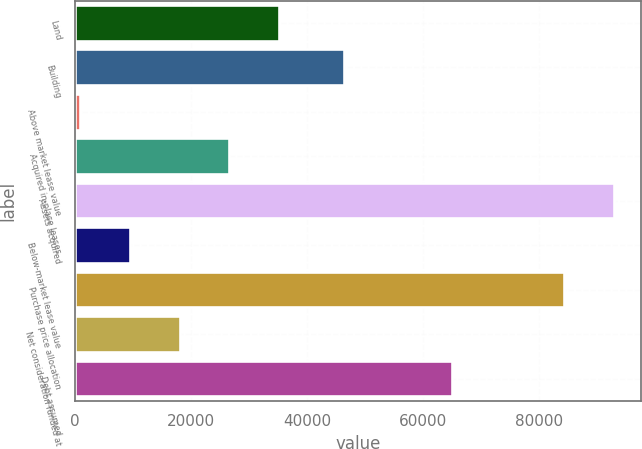<chart> <loc_0><loc_0><loc_500><loc_500><bar_chart><fcel>Land<fcel>Building<fcel>Above market lease value<fcel>Acquired in-place leases<fcel>Assets acquired<fcel>Below-market lease value<fcel>Purchase price allocation<fcel>Net consideration funded at<fcel>Debt assumed<nl><fcel>35145.8<fcel>46411<fcel>823<fcel>26565.1<fcel>92884.7<fcel>9403.7<fcel>84304<fcel>17984.4<fcel>65000<nl></chart> 